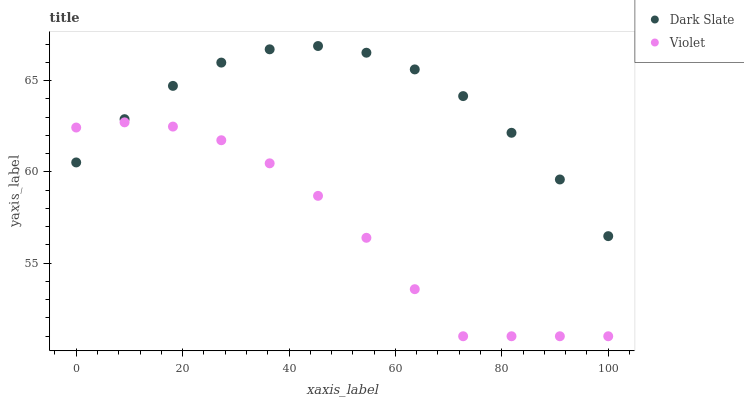Does Violet have the minimum area under the curve?
Answer yes or no. Yes. Does Dark Slate have the maximum area under the curve?
Answer yes or no. Yes. Does Violet have the maximum area under the curve?
Answer yes or no. No. Is Dark Slate the smoothest?
Answer yes or no. Yes. Is Violet the roughest?
Answer yes or no. Yes. Is Violet the smoothest?
Answer yes or no. No. Does Violet have the lowest value?
Answer yes or no. Yes. Does Dark Slate have the highest value?
Answer yes or no. Yes. Does Violet have the highest value?
Answer yes or no. No. Does Violet intersect Dark Slate?
Answer yes or no. Yes. Is Violet less than Dark Slate?
Answer yes or no. No. Is Violet greater than Dark Slate?
Answer yes or no. No. 